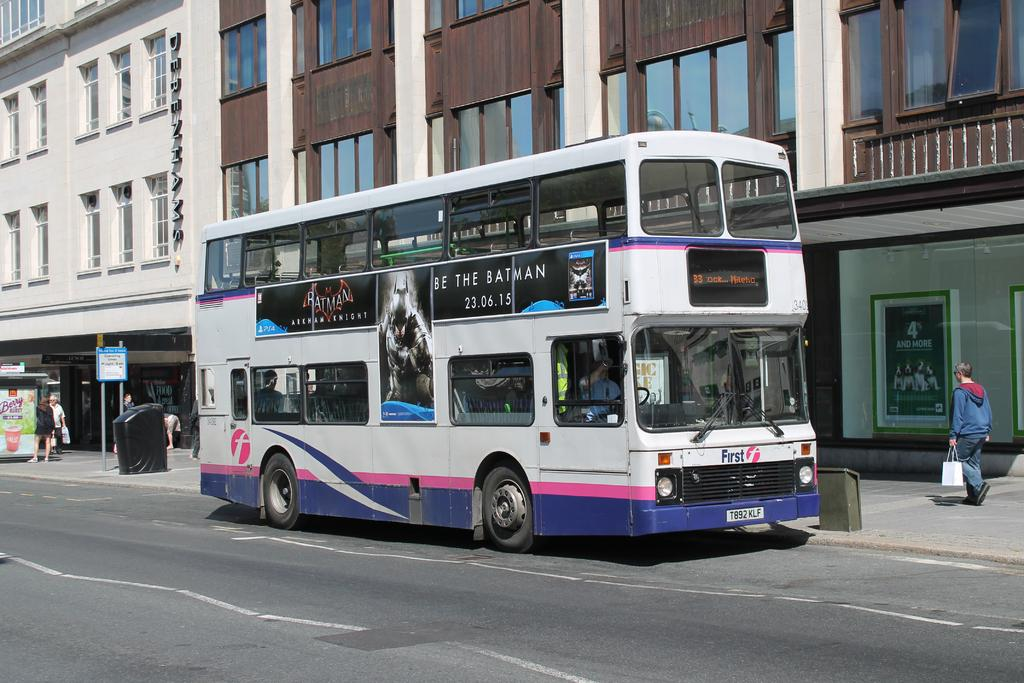<image>
Present a compact description of the photo's key features. A double decker bus with an ad for Batman on the side and the quote, "Be the Batman." 